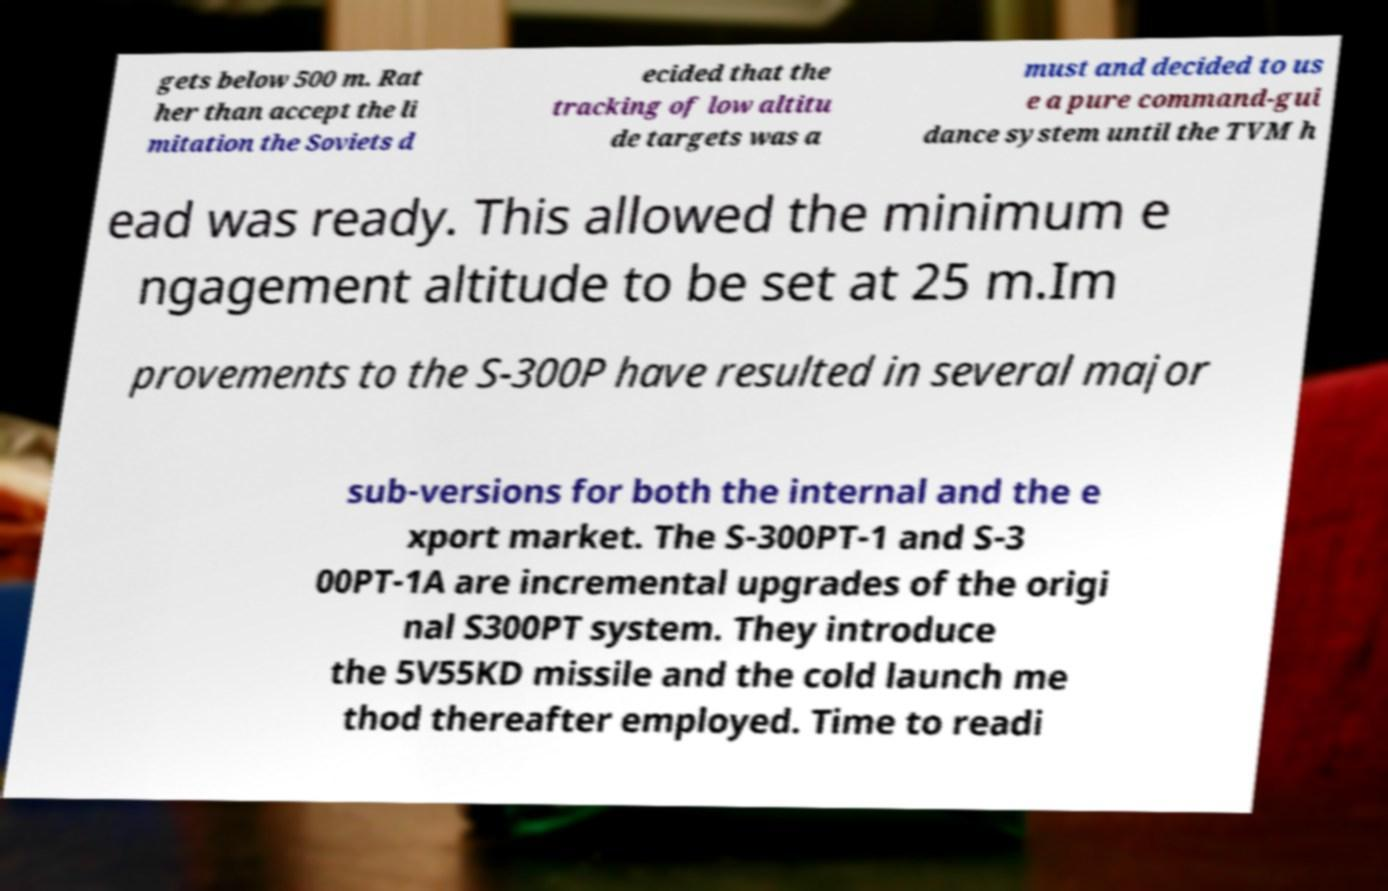Can you read and provide the text displayed in the image?This photo seems to have some interesting text. Can you extract and type it out for me? gets below 500 m. Rat her than accept the li mitation the Soviets d ecided that the tracking of low altitu de targets was a must and decided to us e a pure command-gui dance system until the TVM h ead was ready. This allowed the minimum e ngagement altitude to be set at 25 m.Im provements to the S-300P have resulted in several major sub-versions for both the internal and the e xport market. The S-300PT-1 and S-3 00PT-1A are incremental upgrades of the origi nal S300PT system. They introduce the 5V55KD missile and the cold launch me thod thereafter employed. Time to readi 